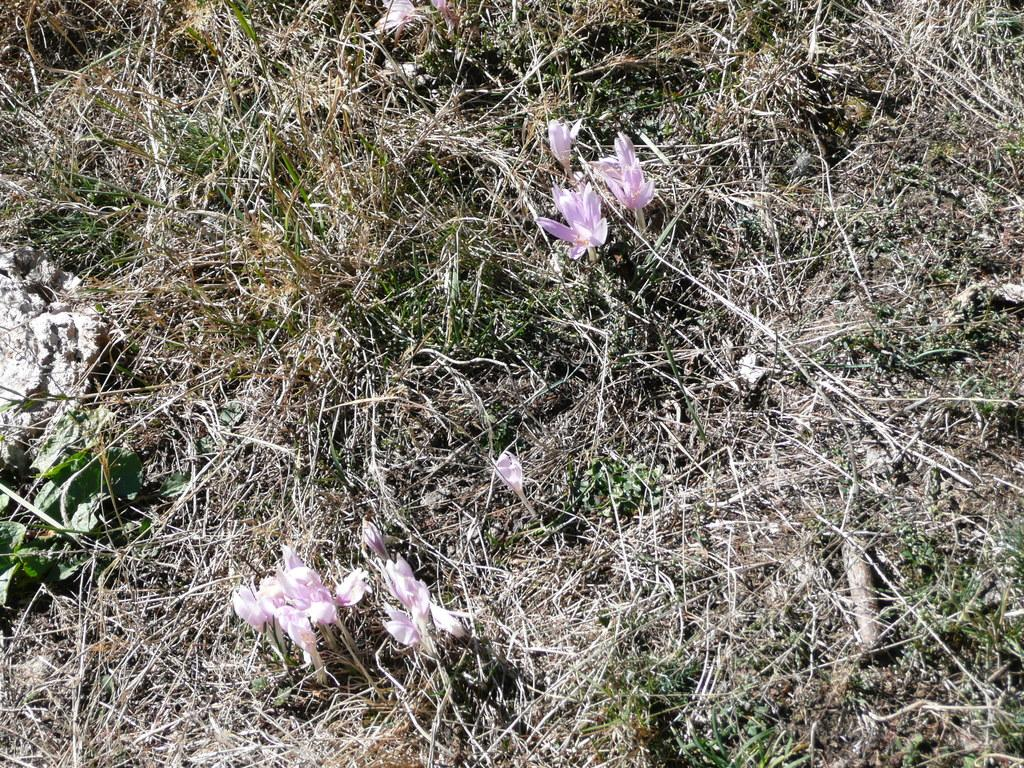What type of vegetation can be seen in the image? There is grass and flowers in the image. Can you describe the colors of the flowers? The colors of the flowers cannot be determined from the provided facts. What might be the purpose of the grass in the image? The purpose of the grass in the image cannot be determined from the provided facts. What type of bait is being used to catch fish in the image? There is no mention of fish or bait in the provided facts, so this question cannot be answered. 